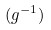<formula> <loc_0><loc_0><loc_500><loc_500>( g ^ { - 1 } )</formula> 